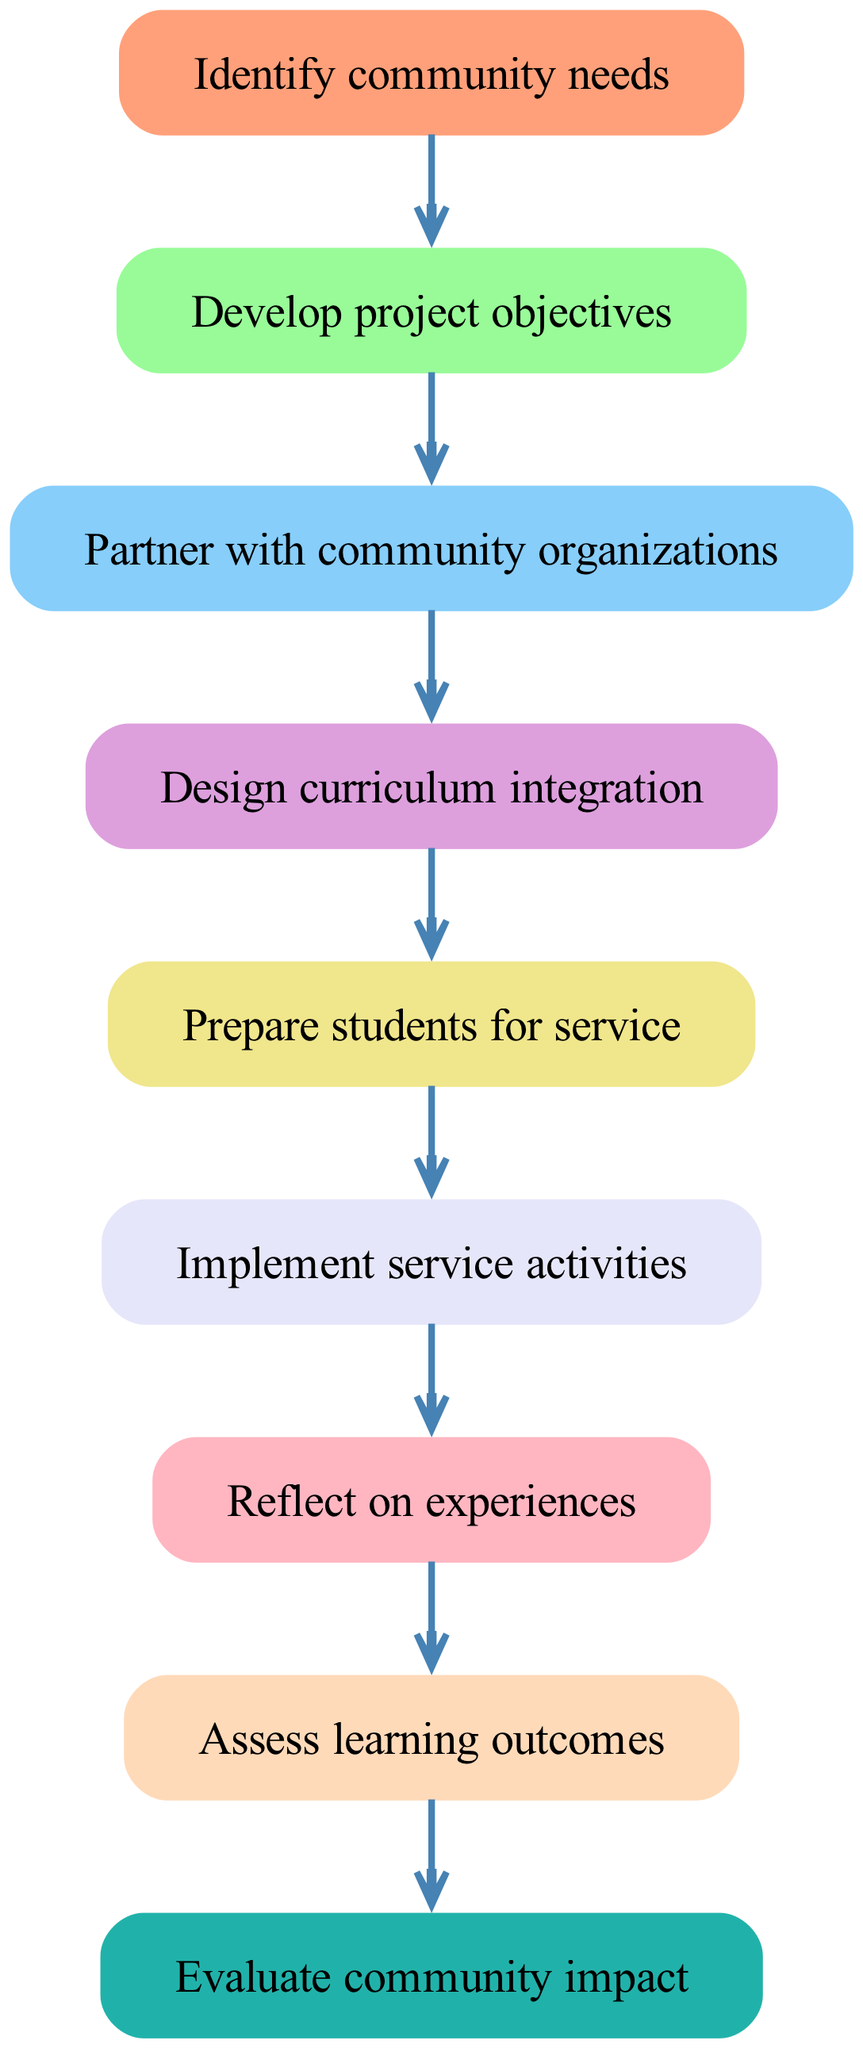What's the starting point of the project flow? The starting point, as indicated in the diagram, is "Identify community needs." This is the first node from which the flow of the service-learning project begins.
Answer: Identify community needs How many nodes are present in the diagram? The diagram has a total of eight nodes, which includes the starting node and seven additional nodes that represent different steps in the service-learning project process.
Answer: 8 What is the last step in the process? The last step shown in the diagram is "Evaluate community impact," which follows the assessment of learning outcomes.
Answer: Evaluate community impact What comes after "Prepare students for service"? Following "Prepare students for service," the next step in the flow is "Implement service activities," indicating that after preparation, students actively engage in service.
Answer: Implement service activities Which node follows "Reflect on experiences"? The node that comes after "Reflect on experiences" is "Assess learning outcomes," suggesting that reflection leads to evaluating what students have learned from their experiences.
Answer: Assess learning outcomes How many edges connect the nodes in the diagram? There are seven edges that connect the nodes in the diagram, indicating the flow from one step to the next in the service-learning project process.
Answer: 7 What is the relationship between "Design curriculum integration" and "Partner with community organizations"? "Partner with community organizations" leads directly to "Design curriculum integration," meaning that once the partnership is established, designing how the project fits into the curriculum follows.
Answer: Partner with community organizations → Design curriculum integration What is the objective of the first node? The objective of the first node, "Identify community needs," is to recognize and understand the needs of the community that will guide the design of the service-learning project.
Answer: Identify community needs What step immediately precedes "Assess learning outcomes"? The step that comes immediately before "Assess learning outcomes" is "Reflect on experiences," indicating that reflection is necessary before evaluation occurs.
Answer: Reflect on experiences 